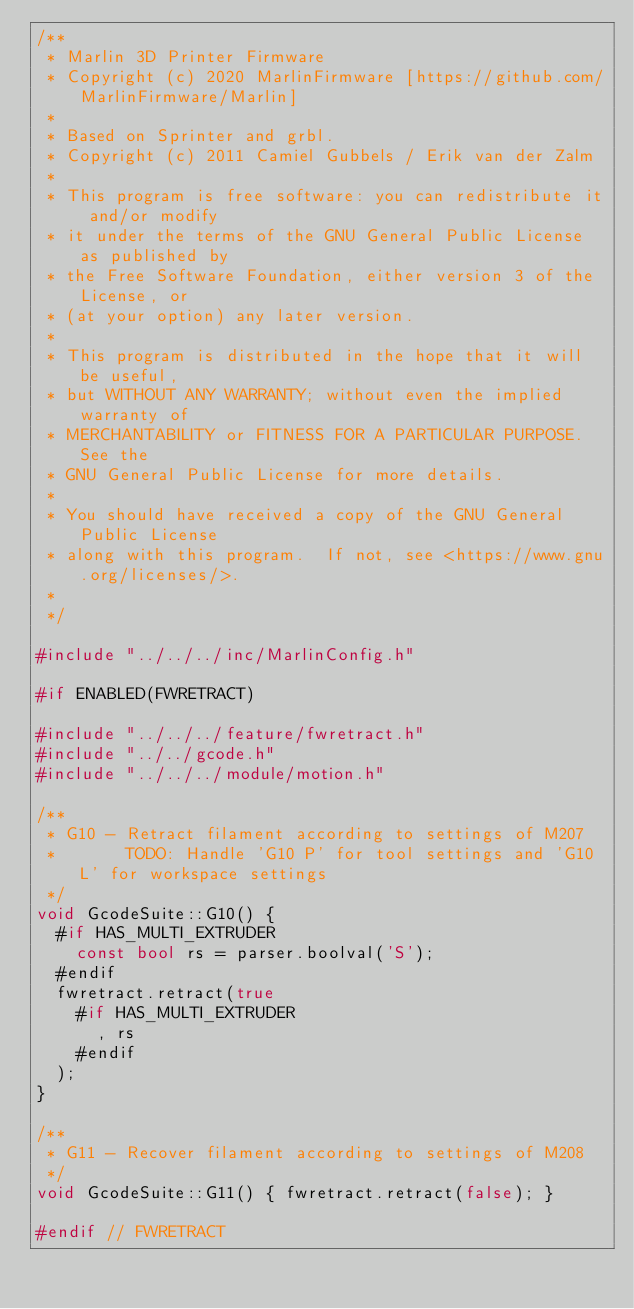<code> <loc_0><loc_0><loc_500><loc_500><_C++_>/**
 * Marlin 3D Printer Firmware
 * Copyright (c) 2020 MarlinFirmware [https://github.com/MarlinFirmware/Marlin]
 *
 * Based on Sprinter and grbl.
 * Copyright (c) 2011 Camiel Gubbels / Erik van der Zalm
 *
 * This program is free software: you can redistribute it and/or modify
 * it under the terms of the GNU General Public License as published by
 * the Free Software Foundation, either version 3 of the License, or
 * (at your option) any later version.
 *
 * This program is distributed in the hope that it will be useful,
 * but WITHOUT ANY WARRANTY; without even the implied warranty of
 * MERCHANTABILITY or FITNESS FOR A PARTICULAR PURPOSE.  See the
 * GNU General Public License for more details.
 *
 * You should have received a copy of the GNU General Public License
 * along with this program.  If not, see <https://www.gnu.org/licenses/>.
 *
 */

#include "../../../inc/MarlinConfig.h"

#if ENABLED(FWRETRACT)

#include "../../../feature/fwretract.h"
#include "../../gcode.h"
#include "../../../module/motion.h"

/**
 * G10 - Retract filament according to settings of M207
 *       TODO: Handle 'G10 P' for tool settings and 'G10 L' for workspace settings
 */
void GcodeSuite::G10() {
  #if HAS_MULTI_EXTRUDER
    const bool rs = parser.boolval('S');
  #endif
  fwretract.retract(true
    #if HAS_MULTI_EXTRUDER
      , rs
    #endif
  );
}

/**
 * G11 - Recover filament according to settings of M208
 */
void GcodeSuite::G11() { fwretract.retract(false); }

#endif // FWRETRACT
</code> 